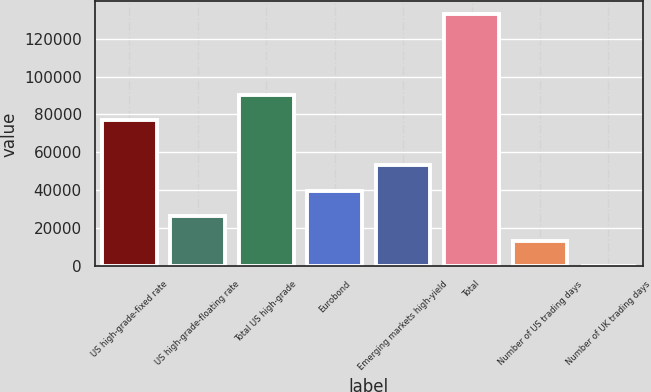Convert chart to OTSL. <chart><loc_0><loc_0><loc_500><loc_500><bar_chart><fcel>US high-grade-fixed rate<fcel>US high-grade-floating rate<fcel>Total US high-grade<fcel>Eurobond<fcel>Emerging markets high-yield<fcel>Total<fcel>Number of US trading days<fcel>Number of UK trading days<nl><fcel>77077<fcel>26640.2<fcel>90367.1<fcel>39930.3<fcel>53220.4<fcel>132961<fcel>13350.1<fcel>60<nl></chart> 